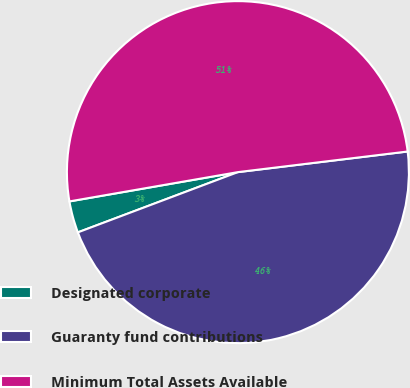Convert chart. <chart><loc_0><loc_0><loc_500><loc_500><pie_chart><fcel>Designated corporate<fcel>Guaranty fund contributions<fcel>Minimum Total Assets Available<nl><fcel>2.99%<fcel>46.19%<fcel>50.81%<nl></chart> 